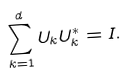<formula> <loc_0><loc_0><loc_500><loc_500>\sum _ { k = 1 } ^ { d } U _ { k } U _ { k } ^ { * } = I .</formula> 